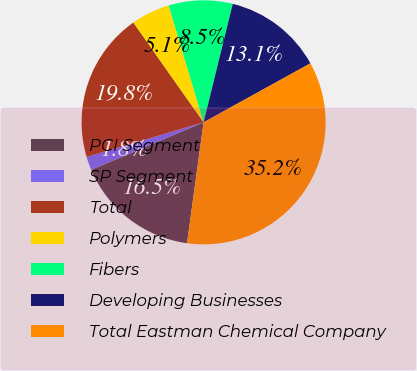Convert chart. <chart><loc_0><loc_0><loc_500><loc_500><pie_chart><fcel>PCI Segment<fcel>SP Segment<fcel>Total<fcel>Polymers<fcel>Fibers<fcel>Developing Businesses<fcel>Total Eastman Chemical Company<nl><fcel>16.47%<fcel>1.79%<fcel>19.81%<fcel>5.13%<fcel>8.47%<fcel>13.13%<fcel>35.2%<nl></chart> 